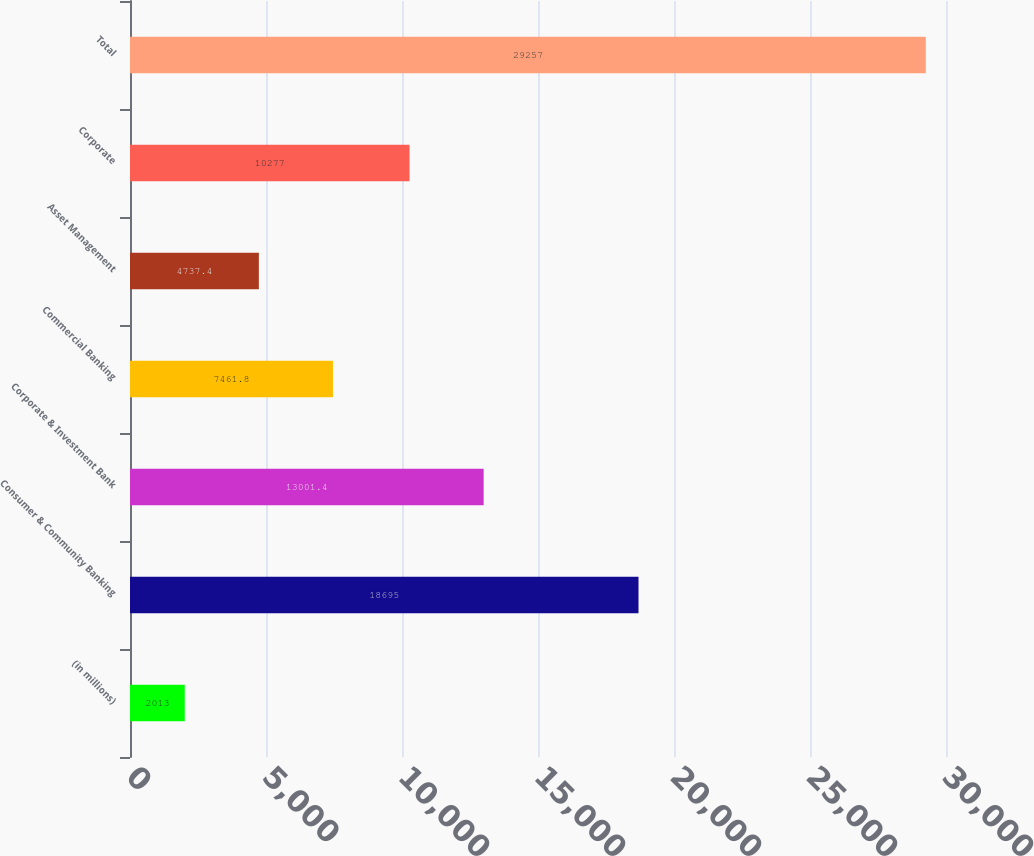Convert chart to OTSL. <chart><loc_0><loc_0><loc_500><loc_500><bar_chart><fcel>(in millions)<fcel>Consumer & Community Banking<fcel>Corporate & Investment Bank<fcel>Commercial Banking<fcel>Asset Management<fcel>Corporate<fcel>Total<nl><fcel>2013<fcel>18695<fcel>13001.4<fcel>7461.8<fcel>4737.4<fcel>10277<fcel>29257<nl></chart> 